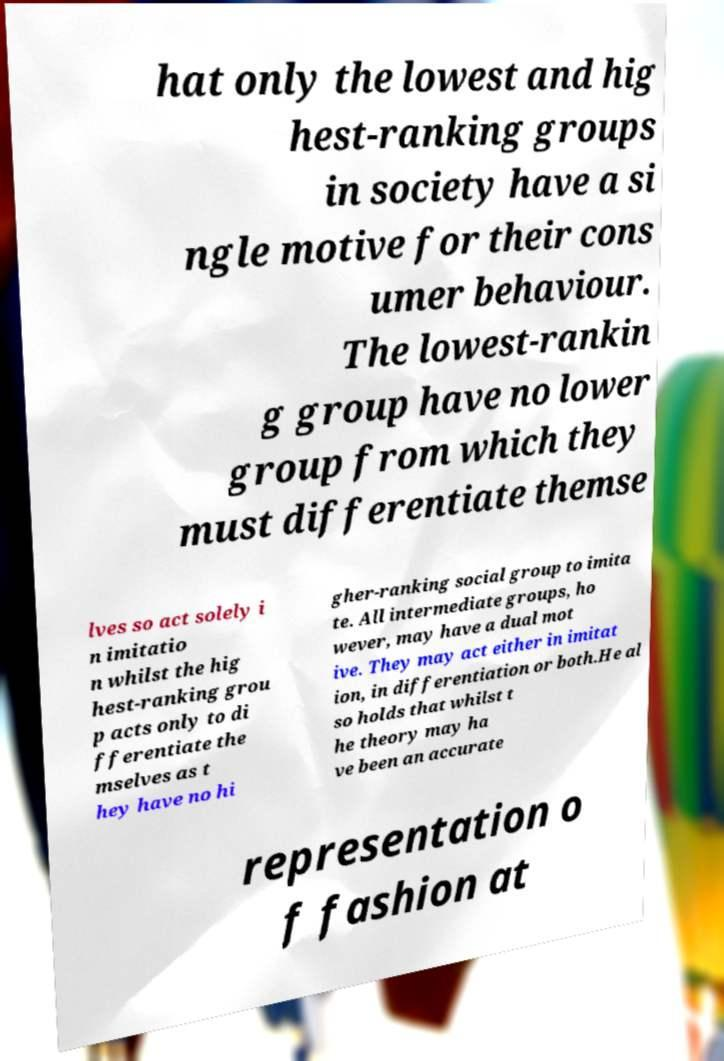There's text embedded in this image that I need extracted. Can you transcribe it verbatim? hat only the lowest and hig hest-ranking groups in society have a si ngle motive for their cons umer behaviour. The lowest-rankin g group have no lower group from which they must differentiate themse lves so act solely i n imitatio n whilst the hig hest-ranking grou p acts only to di fferentiate the mselves as t hey have no hi gher-ranking social group to imita te. All intermediate groups, ho wever, may have a dual mot ive. They may act either in imitat ion, in differentiation or both.He al so holds that whilst t he theory may ha ve been an accurate representation o f fashion at 